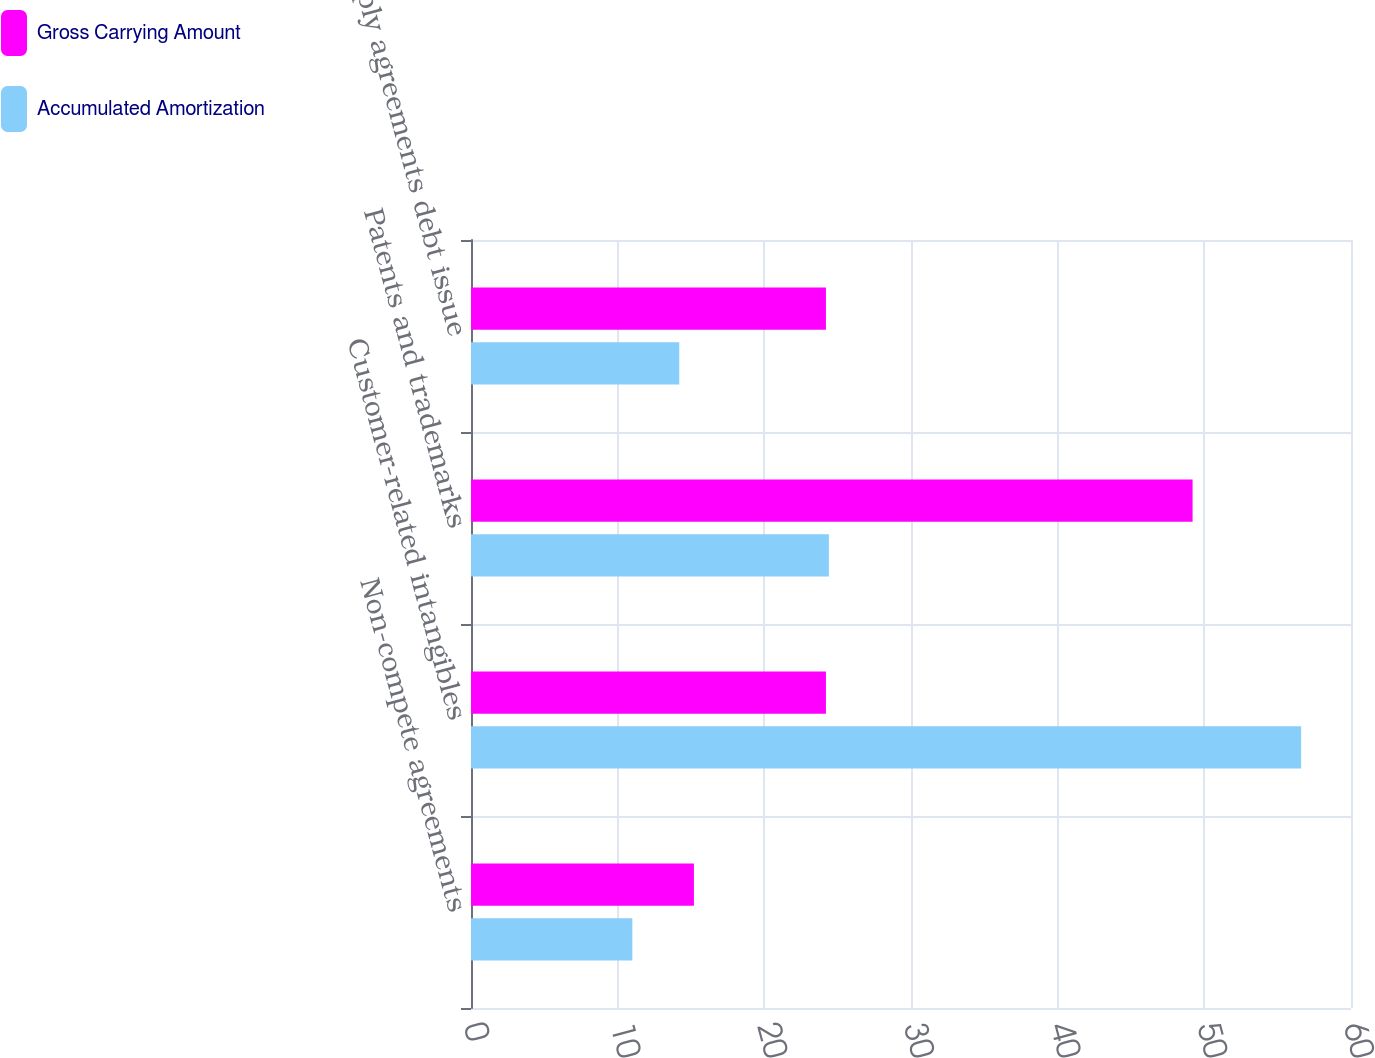Convert chart to OTSL. <chart><loc_0><loc_0><loc_500><loc_500><stacked_bar_chart><ecel><fcel>Non-compete agreements<fcel>Customer-related intangibles<fcel>Patents and trademarks<fcel>Supply agreements debt issue<nl><fcel>Gross Carrying Amount<fcel>15.2<fcel>24.2<fcel>49.2<fcel>24.2<nl><fcel>Accumulated Amortization<fcel>11<fcel>56.6<fcel>24.4<fcel>14.2<nl></chart> 